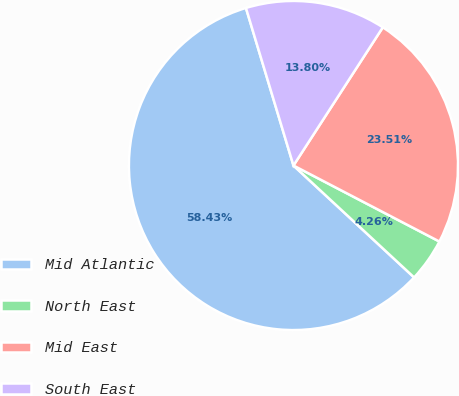<chart> <loc_0><loc_0><loc_500><loc_500><pie_chart><fcel>Mid Atlantic<fcel>North East<fcel>Mid East<fcel>South East<nl><fcel>58.44%<fcel>4.26%<fcel>23.51%<fcel>13.8%<nl></chart> 